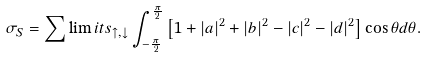<formula> <loc_0><loc_0><loc_500><loc_500>\sigma _ { S } = \mathop \sum \lim i t s _ { \uparrow , \downarrow } \int _ { - \frac { \pi } { 2 } } ^ { \frac { \pi } { 2 } } { \left [ { 1 + \left | a \right | ^ { 2 } + \left | b \right | ^ { 2 } - \left | c \right | ^ { 2 } - \left | d \right | ^ { 2 } } \right ] } \cos \theta d \theta .</formula> 